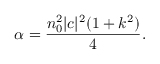Convert formula to latex. <formula><loc_0><loc_0><loc_500><loc_500>\alpha = \frac { n _ { 0 } ^ { 2 } | c | ^ { 2 } ( 1 + k ^ { 2 } ) } { 4 } .</formula> 